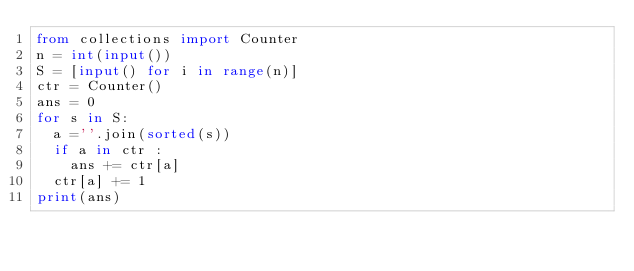<code> <loc_0><loc_0><loc_500><loc_500><_Python_>from collections import Counter
n = int(input())
S = [input() for i in range(n)]
ctr = Counter()
ans = 0
for s in S:
	a =''.join(sorted(s))
	if a in ctr :
		ans += ctr[a]
	ctr[a] += 1
print(ans)

</code> 